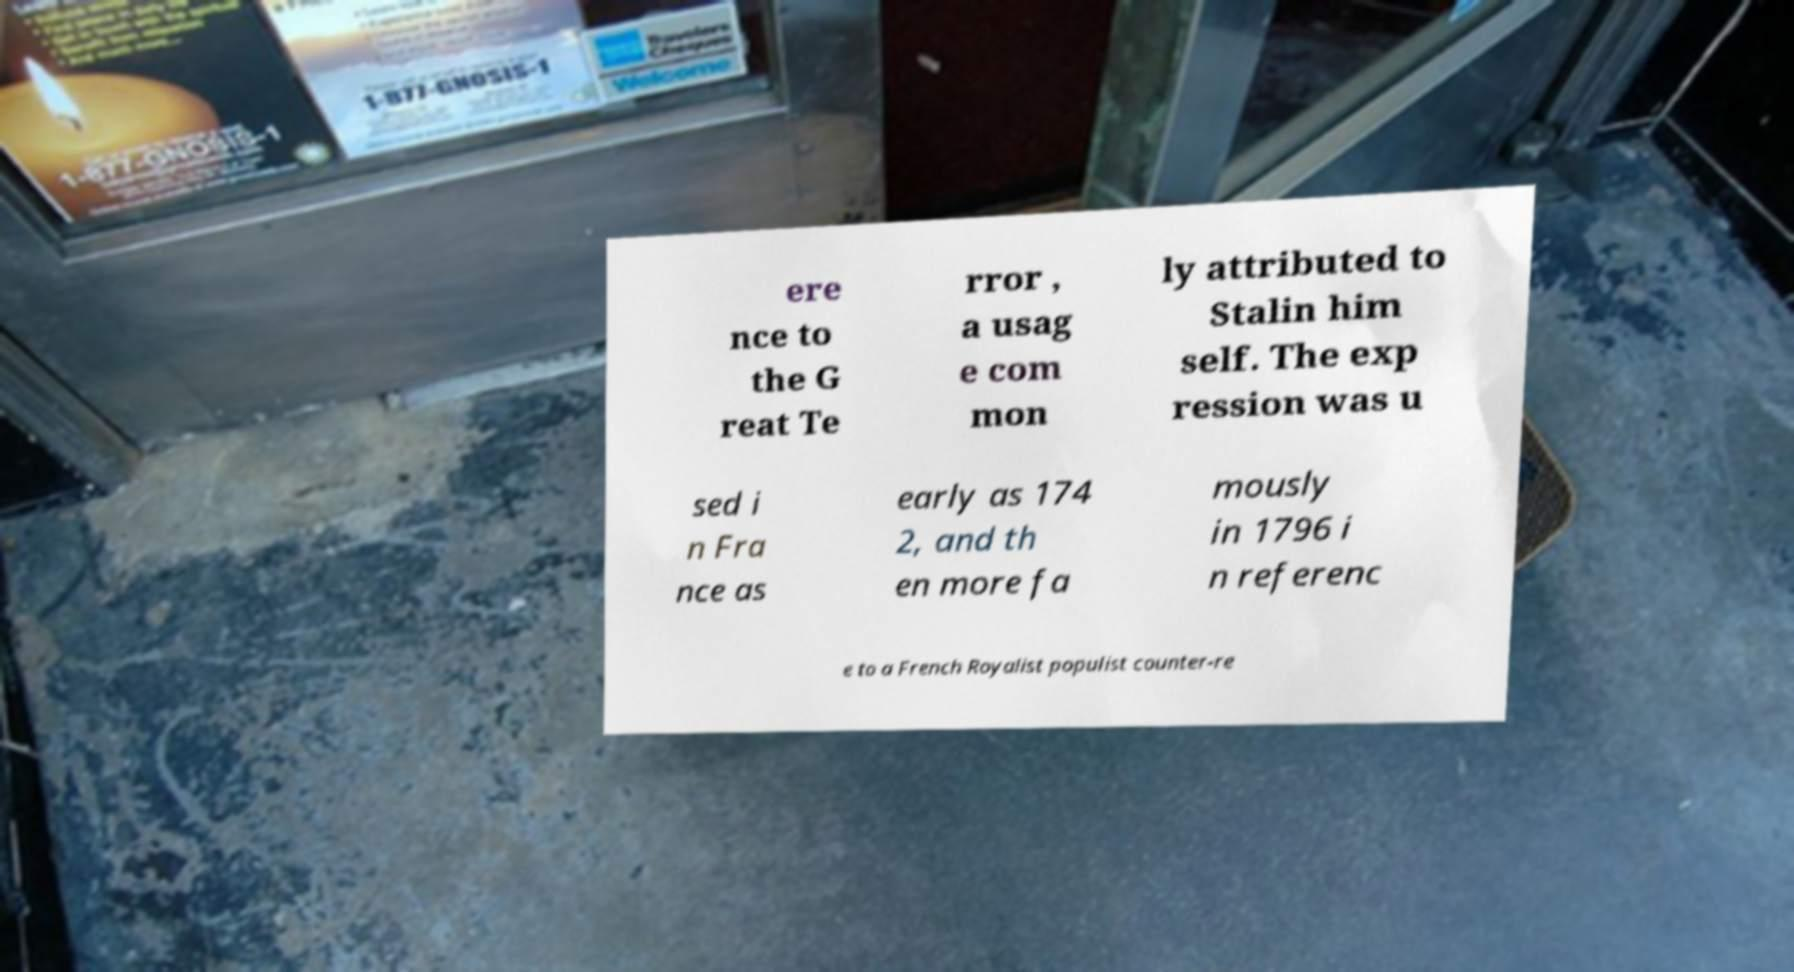For documentation purposes, I need the text within this image transcribed. Could you provide that? ere nce to the G reat Te rror , a usag e com mon ly attributed to Stalin him self. The exp ression was u sed i n Fra nce as early as 174 2, and th en more fa mously in 1796 i n referenc e to a French Royalist populist counter-re 